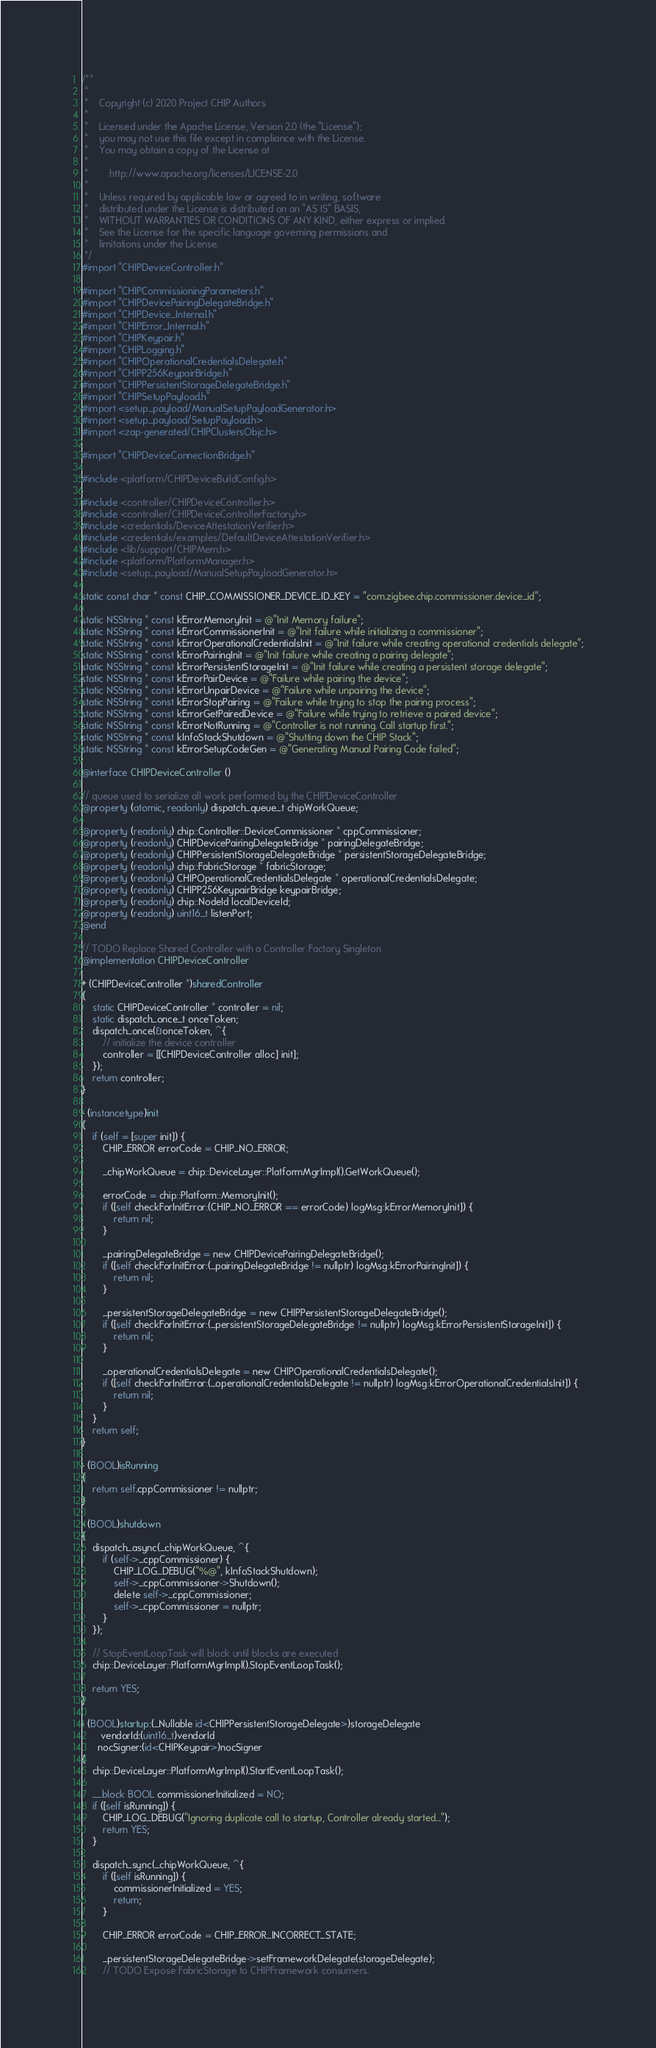<code> <loc_0><loc_0><loc_500><loc_500><_ObjectiveC_>/**
 *
 *    Copyright (c) 2020 Project CHIP Authors
 *
 *    Licensed under the Apache License, Version 2.0 (the "License");
 *    you may not use this file except in compliance with the License.
 *    You may obtain a copy of the License at
 *
 *        http://www.apache.org/licenses/LICENSE-2.0
 *
 *    Unless required by applicable law or agreed to in writing, software
 *    distributed under the License is distributed on an "AS IS" BASIS,
 *    WITHOUT WARRANTIES OR CONDITIONS OF ANY KIND, either express or implied.
 *    See the License for the specific language governing permissions and
 *    limitations under the License.
 */
#import "CHIPDeviceController.h"

#import "CHIPCommissioningParameters.h"
#import "CHIPDevicePairingDelegateBridge.h"
#import "CHIPDevice_Internal.h"
#import "CHIPError_Internal.h"
#import "CHIPKeypair.h"
#import "CHIPLogging.h"
#import "CHIPOperationalCredentialsDelegate.h"
#import "CHIPP256KeypairBridge.h"
#import "CHIPPersistentStorageDelegateBridge.h"
#import "CHIPSetupPayload.h"
#import <setup_payload/ManualSetupPayloadGenerator.h>
#import <setup_payload/SetupPayload.h>
#import <zap-generated/CHIPClustersObjc.h>

#import "CHIPDeviceConnectionBridge.h"

#include <platform/CHIPDeviceBuildConfig.h>

#include <controller/CHIPDeviceController.h>
#include <controller/CHIPDeviceControllerFactory.h>
#include <credentials/DeviceAttestationVerifier.h>
#include <credentials/examples/DefaultDeviceAttestationVerifier.h>
#include <lib/support/CHIPMem.h>
#include <platform/PlatformManager.h>
#include <setup_payload/ManualSetupPayloadGenerator.h>

static const char * const CHIP_COMMISSIONER_DEVICE_ID_KEY = "com.zigbee.chip.commissioner.device_id";

static NSString * const kErrorMemoryInit = @"Init Memory failure";
static NSString * const kErrorCommissionerInit = @"Init failure while initializing a commissioner";
static NSString * const kErrorOperationalCredentialsInit = @"Init failure while creating operational credentials delegate";
static NSString * const kErrorPairingInit = @"Init failure while creating a pairing delegate";
static NSString * const kErrorPersistentStorageInit = @"Init failure while creating a persistent storage delegate";
static NSString * const kErrorPairDevice = @"Failure while pairing the device";
static NSString * const kErrorUnpairDevice = @"Failure while unpairing the device";
static NSString * const kErrorStopPairing = @"Failure while trying to stop the pairing process";
static NSString * const kErrorGetPairedDevice = @"Failure while trying to retrieve a paired device";
static NSString * const kErrorNotRunning = @"Controller is not running. Call startup first.";
static NSString * const kInfoStackShutdown = @"Shutting down the CHIP Stack";
static NSString * const kErrorSetupCodeGen = @"Generating Manual Pairing Code failed";

@interface CHIPDeviceController ()

// queue used to serialize all work performed by the CHIPDeviceController
@property (atomic, readonly) dispatch_queue_t chipWorkQueue;

@property (readonly) chip::Controller::DeviceCommissioner * cppCommissioner;
@property (readonly) CHIPDevicePairingDelegateBridge * pairingDelegateBridge;
@property (readonly) CHIPPersistentStorageDelegateBridge * persistentStorageDelegateBridge;
@property (readonly) chip::FabricStorage * fabricStorage;
@property (readonly) CHIPOperationalCredentialsDelegate * operationalCredentialsDelegate;
@property (readonly) CHIPP256KeypairBridge keypairBridge;
@property (readonly) chip::NodeId localDeviceId;
@property (readonly) uint16_t listenPort;
@end

// TODO Replace Shared Controller with a Controller Factory Singleton
@implementation CHIPDeviceController

+ (CHIPDeviceController *)sharedController
{
    static CHIPDeviceController * controller = nil;
    static dispatch_once_t onceToken;
    dispatch_once(&onceToken, ^{
        // initialize the device controller
        controller = [[CHIPDeviceController alloc] init];
    });
    return controller;
}

- (instancetype)init
{
    if (self = [super init]) {
        CHIP_ERROR errorCode = CHIP_NO_ERROR;

        _chipWorkQueue = chip::DeviceLayer::PlatformMgrImpl().GetWorkQueue();

        errorCode = chip::Platform::MemoryInit();
        if ([self checkForInitError:(CHIP_NO_ERROR == errorCode) logMsg:kErrorMemoryInit]) {
            return nil;
        }

        _pairingDelegateBridge = new CHIPDevicePairingDelegateBridge();
        if ([self checkForInitError:(_pairingDelegateBridge != nullptr) logMsg:kErrorPairingInit]) {
            return nil;
        }

        _persistentStorageDelegateBridge = new CHIPPersistentStorageDelegateBridge();
        if ([self checkForInitError:(_persistentStorageDelegateBridge != nullptr) logMsg:kErrorPersistentStorageInit]) {
            return nil;
        }

        _operationalCredentialsDelegate = new CHIPOperationalCredentialsDelegate();
        if ([self checkForInitError:(_operationalCredentialsDelegate != nullptr) logMsg:kErrorOperationalCredentialsInit]) {
            return nil;
        }
    }
    return self;
}

- (BOOL)isRunning
{
    return self.cppCommissioner != nullptr;
}

- (BOOL)shutdown
{
    dispatch_async(_chipWorkQueue, ^{
        if (self->_cppCommissioner) {
            CHIP_LOG_DEBUG("%@", kInfoStackShutdown);
            self->_cppCommissioner->Shutdown();
            delete self->_cppCommissioner;
            self->_cppCommissioner = nullptr;
        }
    });

    // StopEventLoopTask will block until blocks are executed
    chip::DeviceLayer::PlatformMgrImpl().StopEventLoopTask();

    return YES;
}

- (BOOL)startup:(_Nullable id<CHIPPersistentStorageDelegate>)storageDelegate
       vendorId:(uint16_t)vendorId
      nocSigner:(id<CHIPKeypair>)nocSigner
{
    chip::DeviceLayer::PlatformMgrImpl().StartEventLoopTask();

    __block BOOL commissionerInitialized = NO;
    if ([self isRunning]) {
        CHIP_LOG_DEBUG("Ignoring duplicate call to startup, Controller already started...");
        return YES;
    }

    dispatch_sync(_chipWorkQueue, ^{
        if ([self isRunning]) {
            commissionerInitialized = YES;
            return;
        }

        CHIP_ERROR errorCode = CHIP_ERROR_INCORRECT_STATE;

        _persistentStorageDelegateBridge->setFrameworkDelegate(storageDelegate);
        // TODO Expose FabricStorage to CHIPFramework consumers.</code> 